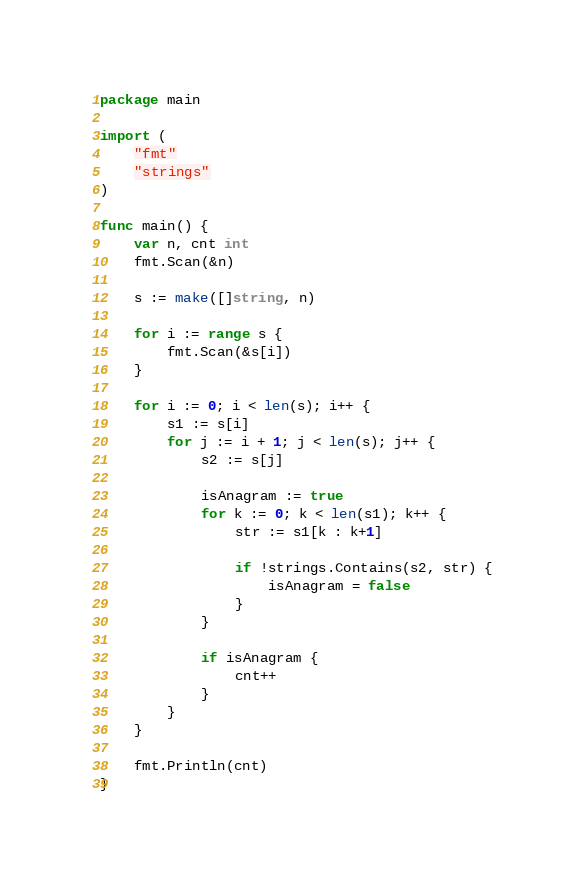<code> <loc_0><loc_0><loc_500><loc_500><_Go_>package main

import (
	"fmt"
	"strings"
)

func main() {
	var n, cnt int
	fmt.Scan(&n)

	s := make([]string, n)

	for i := range s {
		fmt.Scan(&s[i])
	}

	for i := 0; i < len(s); i++ {
		s1 := s[i]
		for j := i + 1; j < len(s); j++ {
			s2 := s[j]

			isAnagram := true
			for k := 0; k < len(s1); k++ {
				str := s1[k : k+1]

				if !strings.Contains(s2, str) {
					isAnagram = false
				}
			}

			if isAnagram {
				cnt++
			}
		}
	}

	fmt.Println(cnt)
}
</code> 